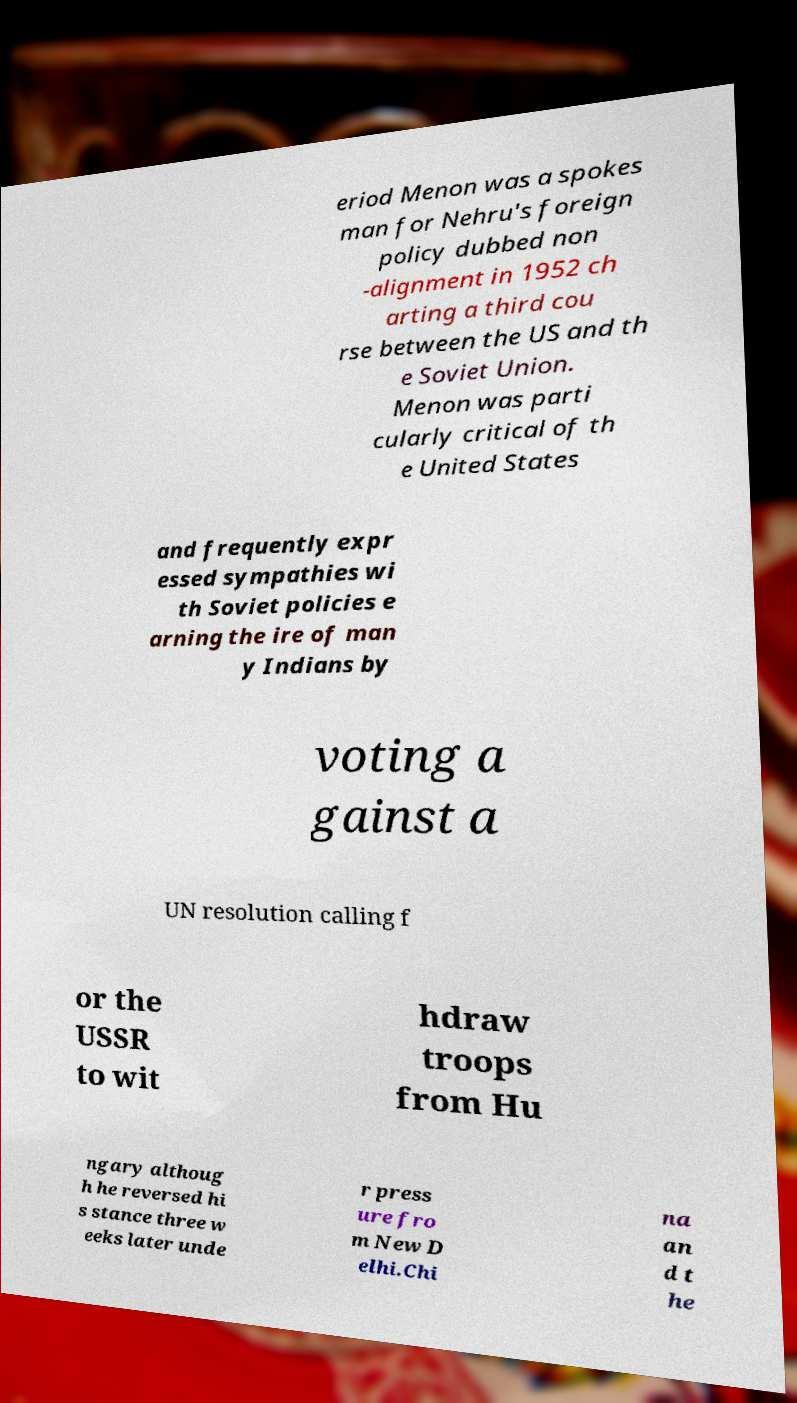Could you assist in decoding the text presented in this image and type it out clearly? eriod Menon was a spokes man for Nehru's foreign policy dubbed non -alignment in 1952 ch arting a third cou rse between the US and th e Soviet Union. Menon was parti cularly critical of th e United States and frequently expr essed sympathies wi th Soviet policies e arning the ire of man y Indians by voting a gainst a UN resolution calling f or the USSR to wit hdraw troops from Hu ngary althoug h he reversed hi s stance three w eeks later unde r press ure fro m New D elhi.Chi na an d t he 